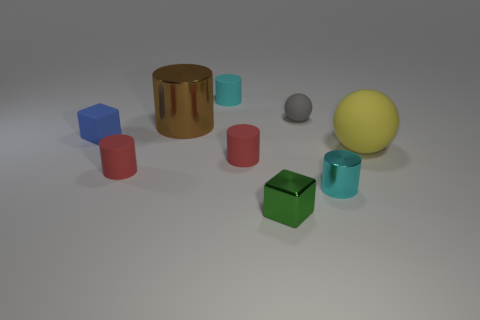Subtract all cyan blocks. How many cyan cylinders are left? 2 Subtract all cyan cylinders. How many cylinders are left? 3 Subtract all big cylinders. How many cylinders are left? 4 Subtract all blue cylinders. Subtract all cyan cubes. How many cylinders are left? 5 Add 1 red rubber cylinders. How many objects exist? 10 Subtract all blocks. How many objects are left? 7 Subtract all small cyan matte cylinders. Subtract all tiny cyan rubber things. How many objects are left? 7 Add 1 gray balls. How many gray balls are left? 2 Add 2 small cyan rubber cylinders. How many small cyan rubber cylinders exist? 3 Subtract 1 blue cubes. How many objects are left? 8 